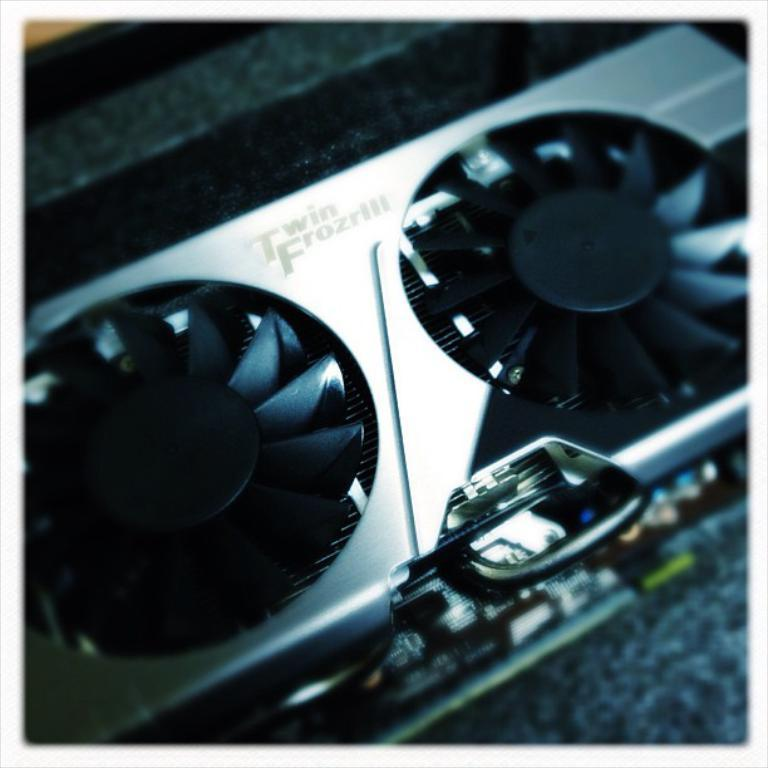What type of electronic equipment is visible in the image? The electronic equipment is not specified, but it has fans present on it. Can you describe the fans on the electronic equipment? The fans are present on the electronic equipment, but their size, shape, or number are not mentioned. What type of thunder can be heard coming from the electronic equipment in the image? There is no mention of thunder or any sound in the image, as it only features electronic equipment with fans. 